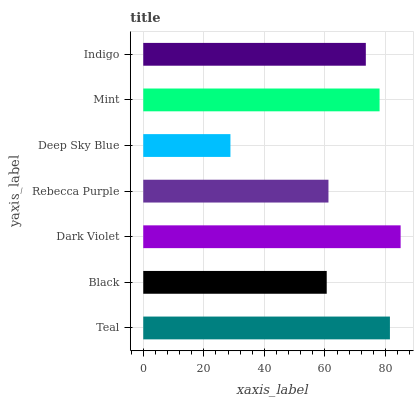Is Deep Sky Blue the minimum?
Answer yes or no. Yes. Is Dark Violet the maximum?
Answer yes or no. Yes. Is Black the minimum?
Answer yes or no. No. Is Black the maximum?
Answer yes or no. No. Is Teal greater than Black?
Answer yes or no. Yes. Is Black less than Teal?
Answer yes or no. Yes. Is Black greater than Teal?
Answer yes or no. No. Is Teal less than Black?
Answer yes or no. No. Is Indigo the high median?
Answer yes or no. Yes. Is Indigo the low median?
Answer yes or no. Yes. Is Deep Sky Blue the high median?
Answer yes or no. No. Is Rebecca Purple the low median?
Answer yes or no. No. 